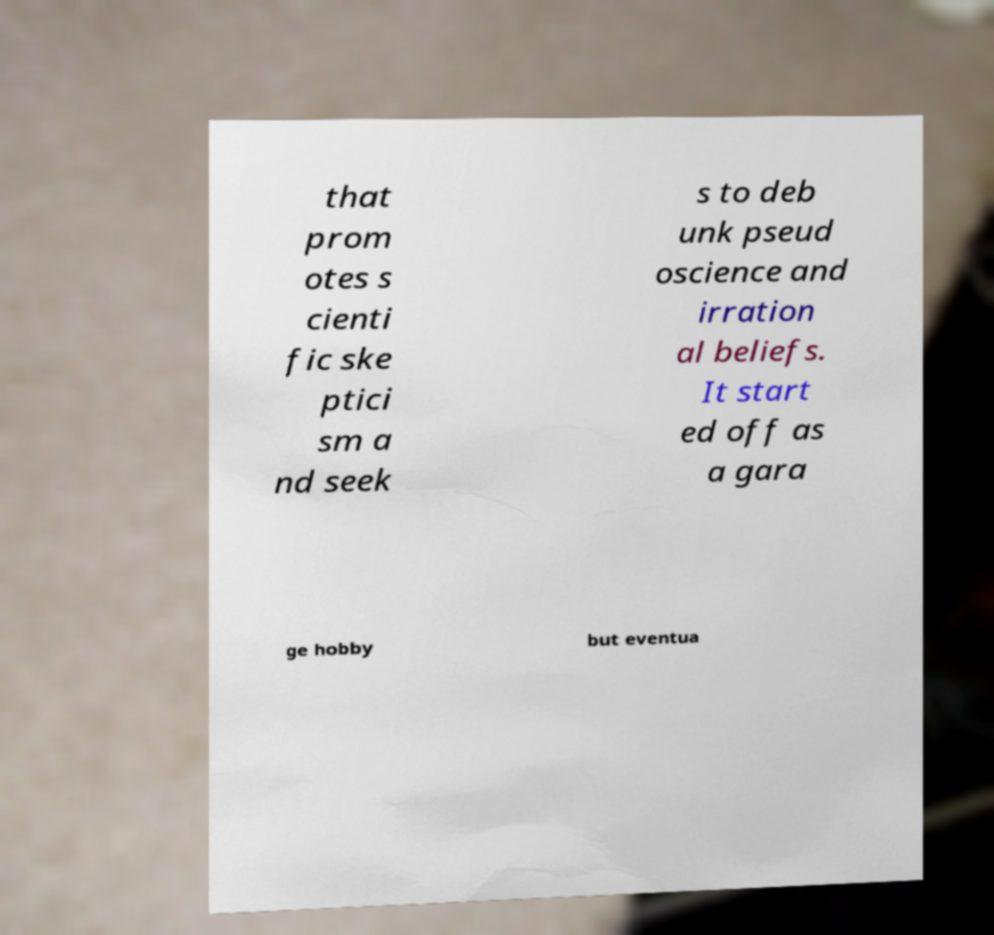There's text embedded in this image that I need extracted. Can you transcribe it verbatim? that prom otes s cienti fic ske ptici sm a nd seek s to deb unk pseud oscience and irration al beliefs. It start ed off as a gara ge hobby but eventua 